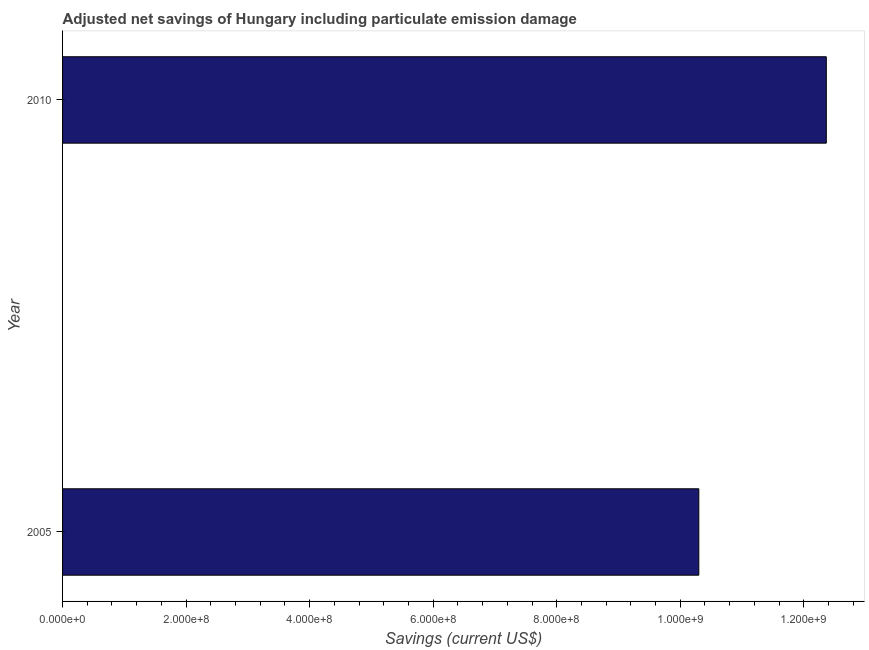Does the graph contain any zero values?
Give a very brief answer. No. What is the title of the graph?
Provide a short and direct response. Adjusted net savings of Hungary including particulate emission damage. What is the label or title of the X-axis?
Your answer should be very brief. Savings (current US$). What is the adjusted net savings in 2010?
Your answer should be very brief. 1.24e+09. Across all years, what is the maximum adjusted net savings?
Your answer should be compact. 1.24e+09. Across all years, what is the minimum adjusted net savings?
Ensure brevity in your answer.  1.03e+09. In which year was the adjusted net savings maximum?
Offer a very short reply. 2010. In which year was the adjusted net savings minimum?
Offer a terse response. 2005. What is the sum of the adjusted net savings?
Provide a short and direct response. 2.27e+09. What is the difference between the adjusted net savings in 2005 and 2010?
Offer a very short reply. -2.06e+08. What is the average adjusted net savings per year?
Make the answer very short. 1.13e+09. What is the median adjusted net savings?
Keep it short and to the point. 1.13e+09. What is the ratio of the adjusted net savings in 2005 to that in 2010?
Offer a terse response. 0.83. Is the adjusted net savings in 2005 less than that in 2010?
Ensure brevity in your answer.  Yes. In how many years, is the adjusted net savings greater than the average adjusted net savings taken over all years?
Keep it short and to the point. 1. Are all the bars in the graph horizontal?
Offer a terse response. Yes. What is the difference between two consecutive major ticks on the X-axis?
Offer a terse response. 2.00e+08. Are the values on the major ticks of X-axis written in scientific E-notation?
Offer a very short reply. Yes. What is the Savings (current US$) in 2005?
Your answer should be compact. 1.03e+09. What is the Savings (current US$) in 2010?
Provide a short and direct response. 1.24e+09. What is the difference between the Savings (current US$) in 2005 and 2010?
Provide a short and direct response. -2.06e+08. What is the ratio of the Savings (current US$) in 2005 to that in 2010?
Make the answer very short. 0.83. 